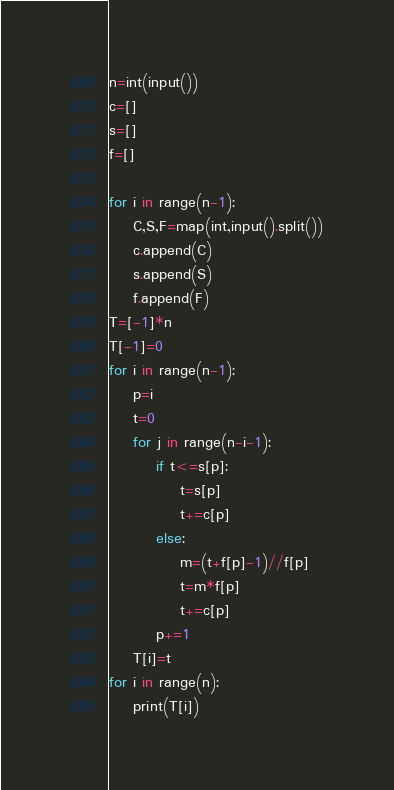Convert code to text. <code><loc_0><loc_0><loc_500><loc_500><_Python_>n=int(input())
c=[]
s=[]
f=[]

for i in range(n-1):
    C,S,F=map(int,input().split())
    c.append(C)
    s.append(S)
    f.append(F)
T=[-1]*n
T[-1]=0
for i in range(n-1):
    p=i
    t=0
    for j in range(n-i-1):
        if t<=s[p]:
            t=s[p]
            t+=c[p]
        else:
            m=(t+f[p]-1)//f[p]
            t=m*f[p]
            t+=c[p]
        p+=1
    T[i]=t
for i in range(n):
    print(T[i])
</code> 